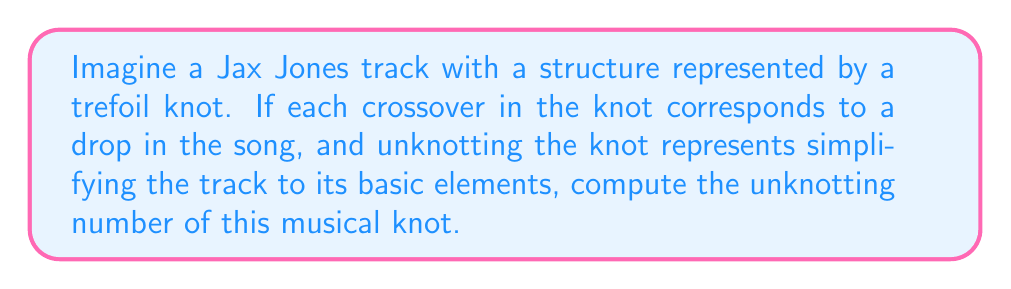Give your solution to this math problem. To solve this problem, we need to understand the concept of unknotting number and apply it to the trefoil knot, which we're using to represent the structure of a Jax Jones track.

Step 1: Understand the unknotting number
The unknotting number of a knot is the minimum number of crossing changes required to transform the knot into the unknot (a simple closed loop with no crossings).

Step 2: Identify the knot
We're dealing with a trefoil knot, which is one of the simplest non-trivial knots.

Step 3: Visualize the trefoil knot
[asy]
import geometry;

path p = (0,0)..(1,1)..(0,2)..(-1,1)..(0,0);
path q = (0,0.9)..(0.9,0.9)..(0.9,0);

draw(p,linewidth(1));
draw(q,linewidth(1));
[/asy]

Step 4: Analyze the crossings
The trefoil knot has three crossings.

Step 5: Determine the unknotting number
For the trefoil knot, changing any one of the crossings will not result in an unknot. However, changing any two of the three crossings will transform the trefoil into an unknot.

Step 6: Interpret in the context of the Jax Jones track
Each crossing change represents simplifying a drop in the song. The unknotting number tells us the minimum number of drops that need to be simplified to reduce the track to its most basic form.

Therefore, the unknotting number of the trefoil knot, and consequently the number of drops that need to be simplified in our hypothetical Jax Jones track, is 1.
Answer: 1 